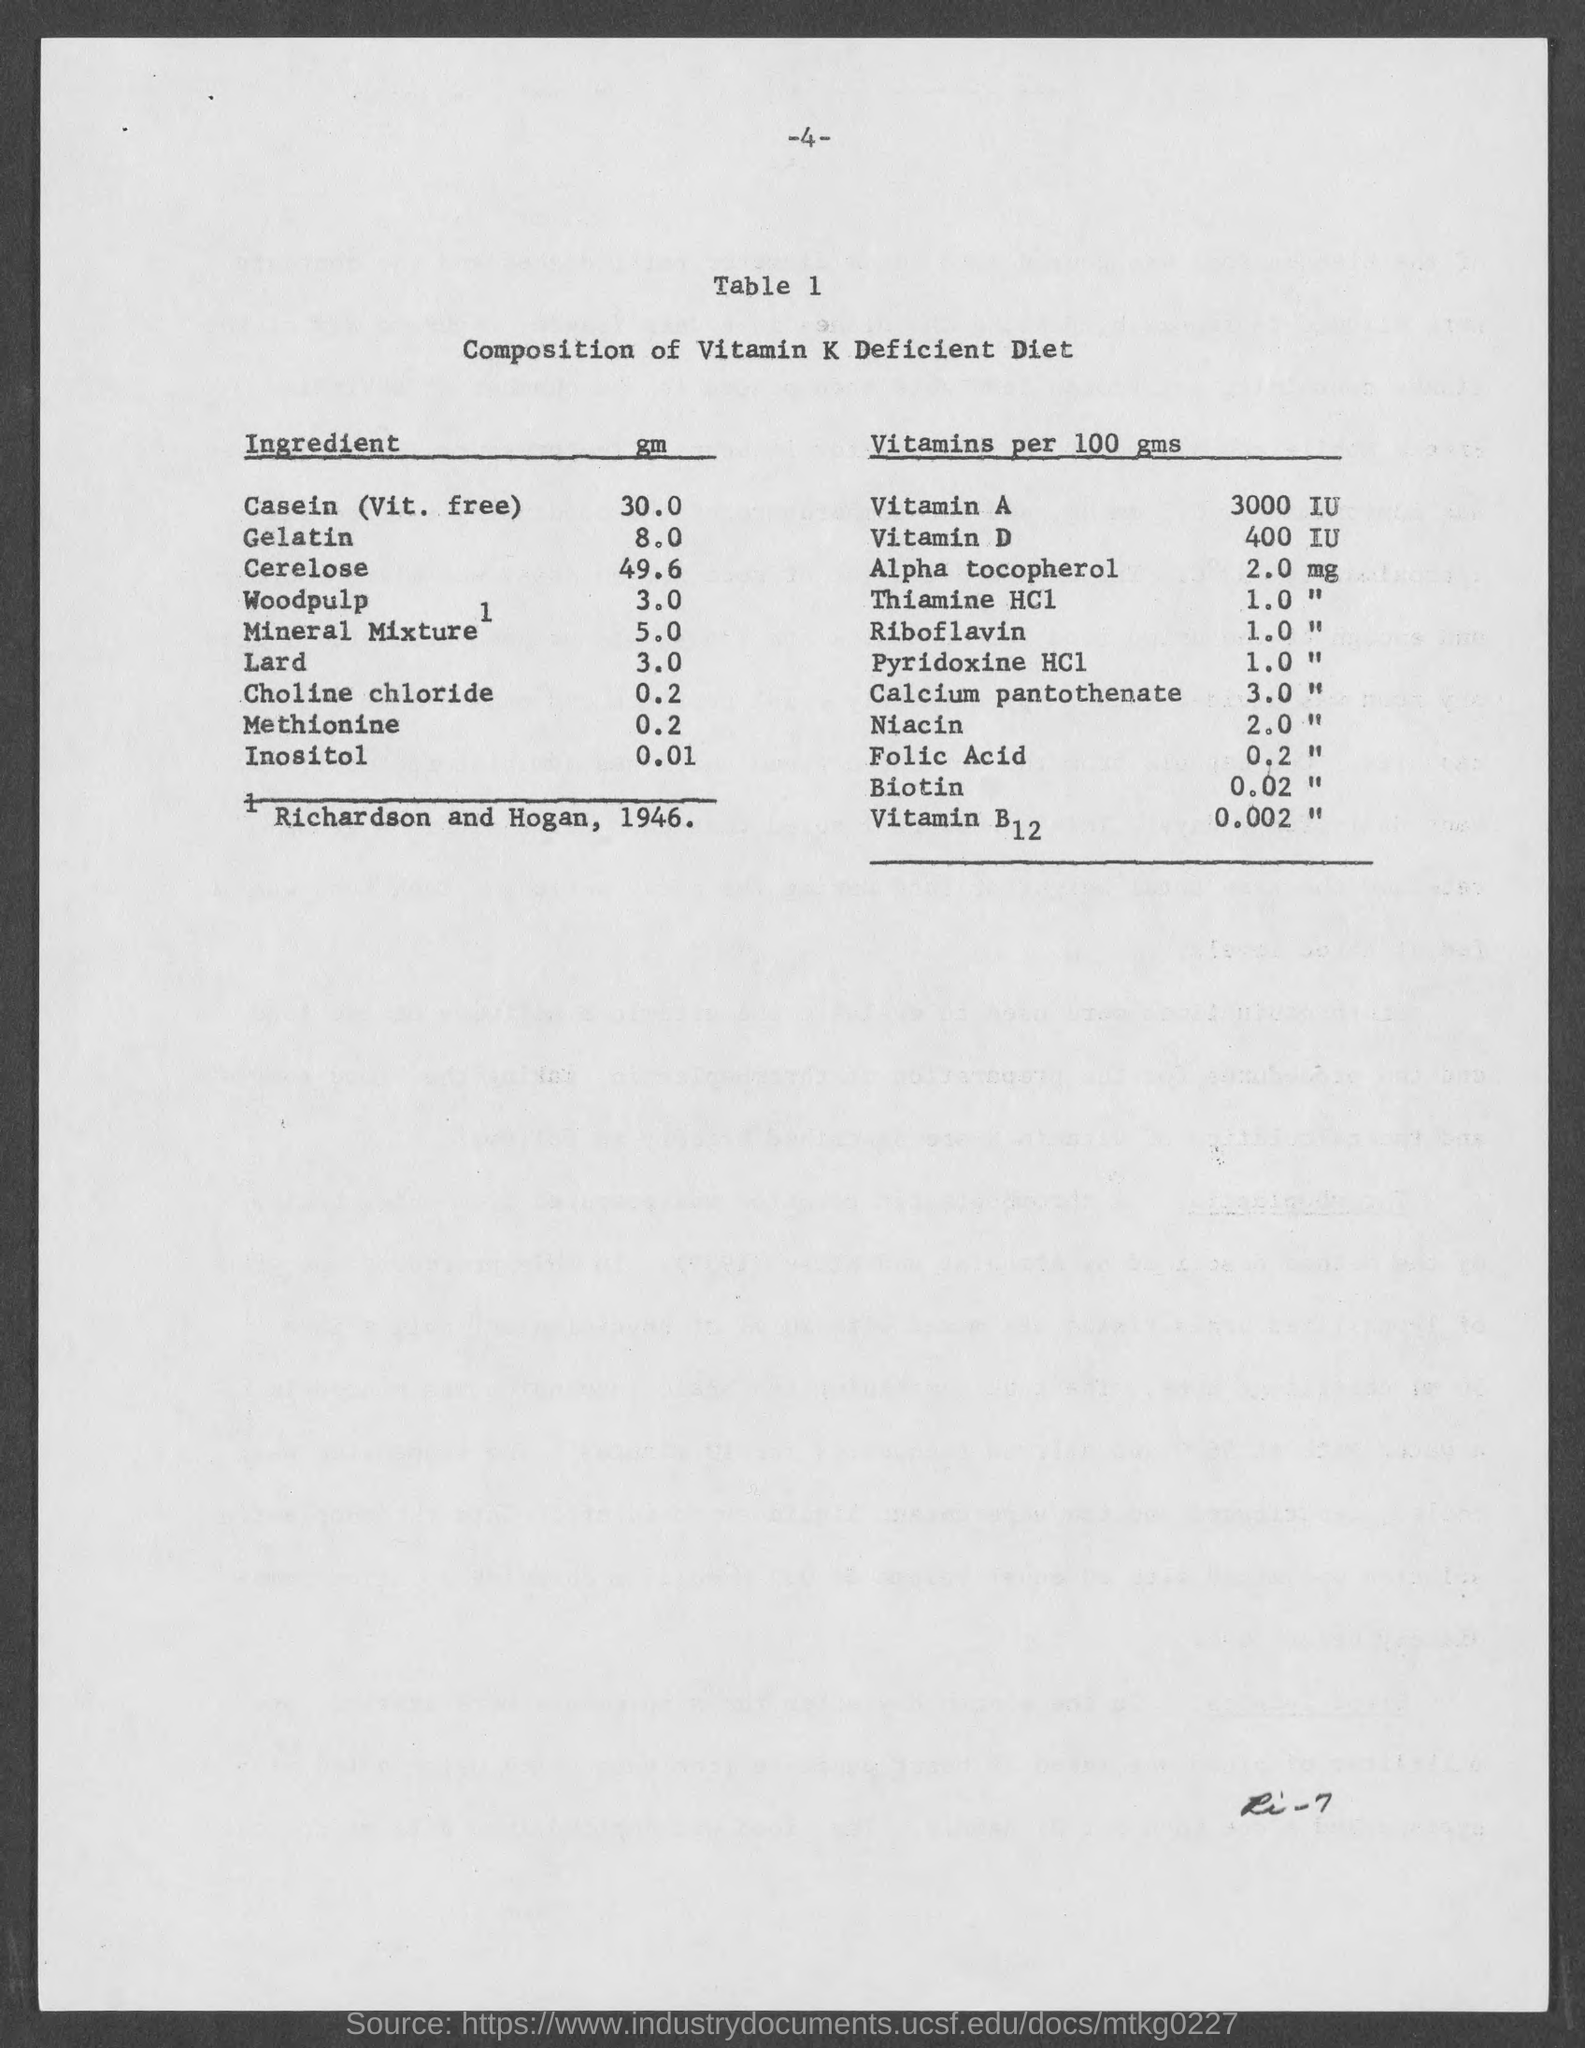Draw attention to some important aspects in this diagram. There is 2.0 milligrams of alpha-tocopherol in 100 grams. There is 10,000 IU of Vitamin A in 100 grams. Table 1 is titled 'Composition of Vitamin K Deficient Diet'. There is 400 International Units (IU) of Vitamin D in 100 grams. 